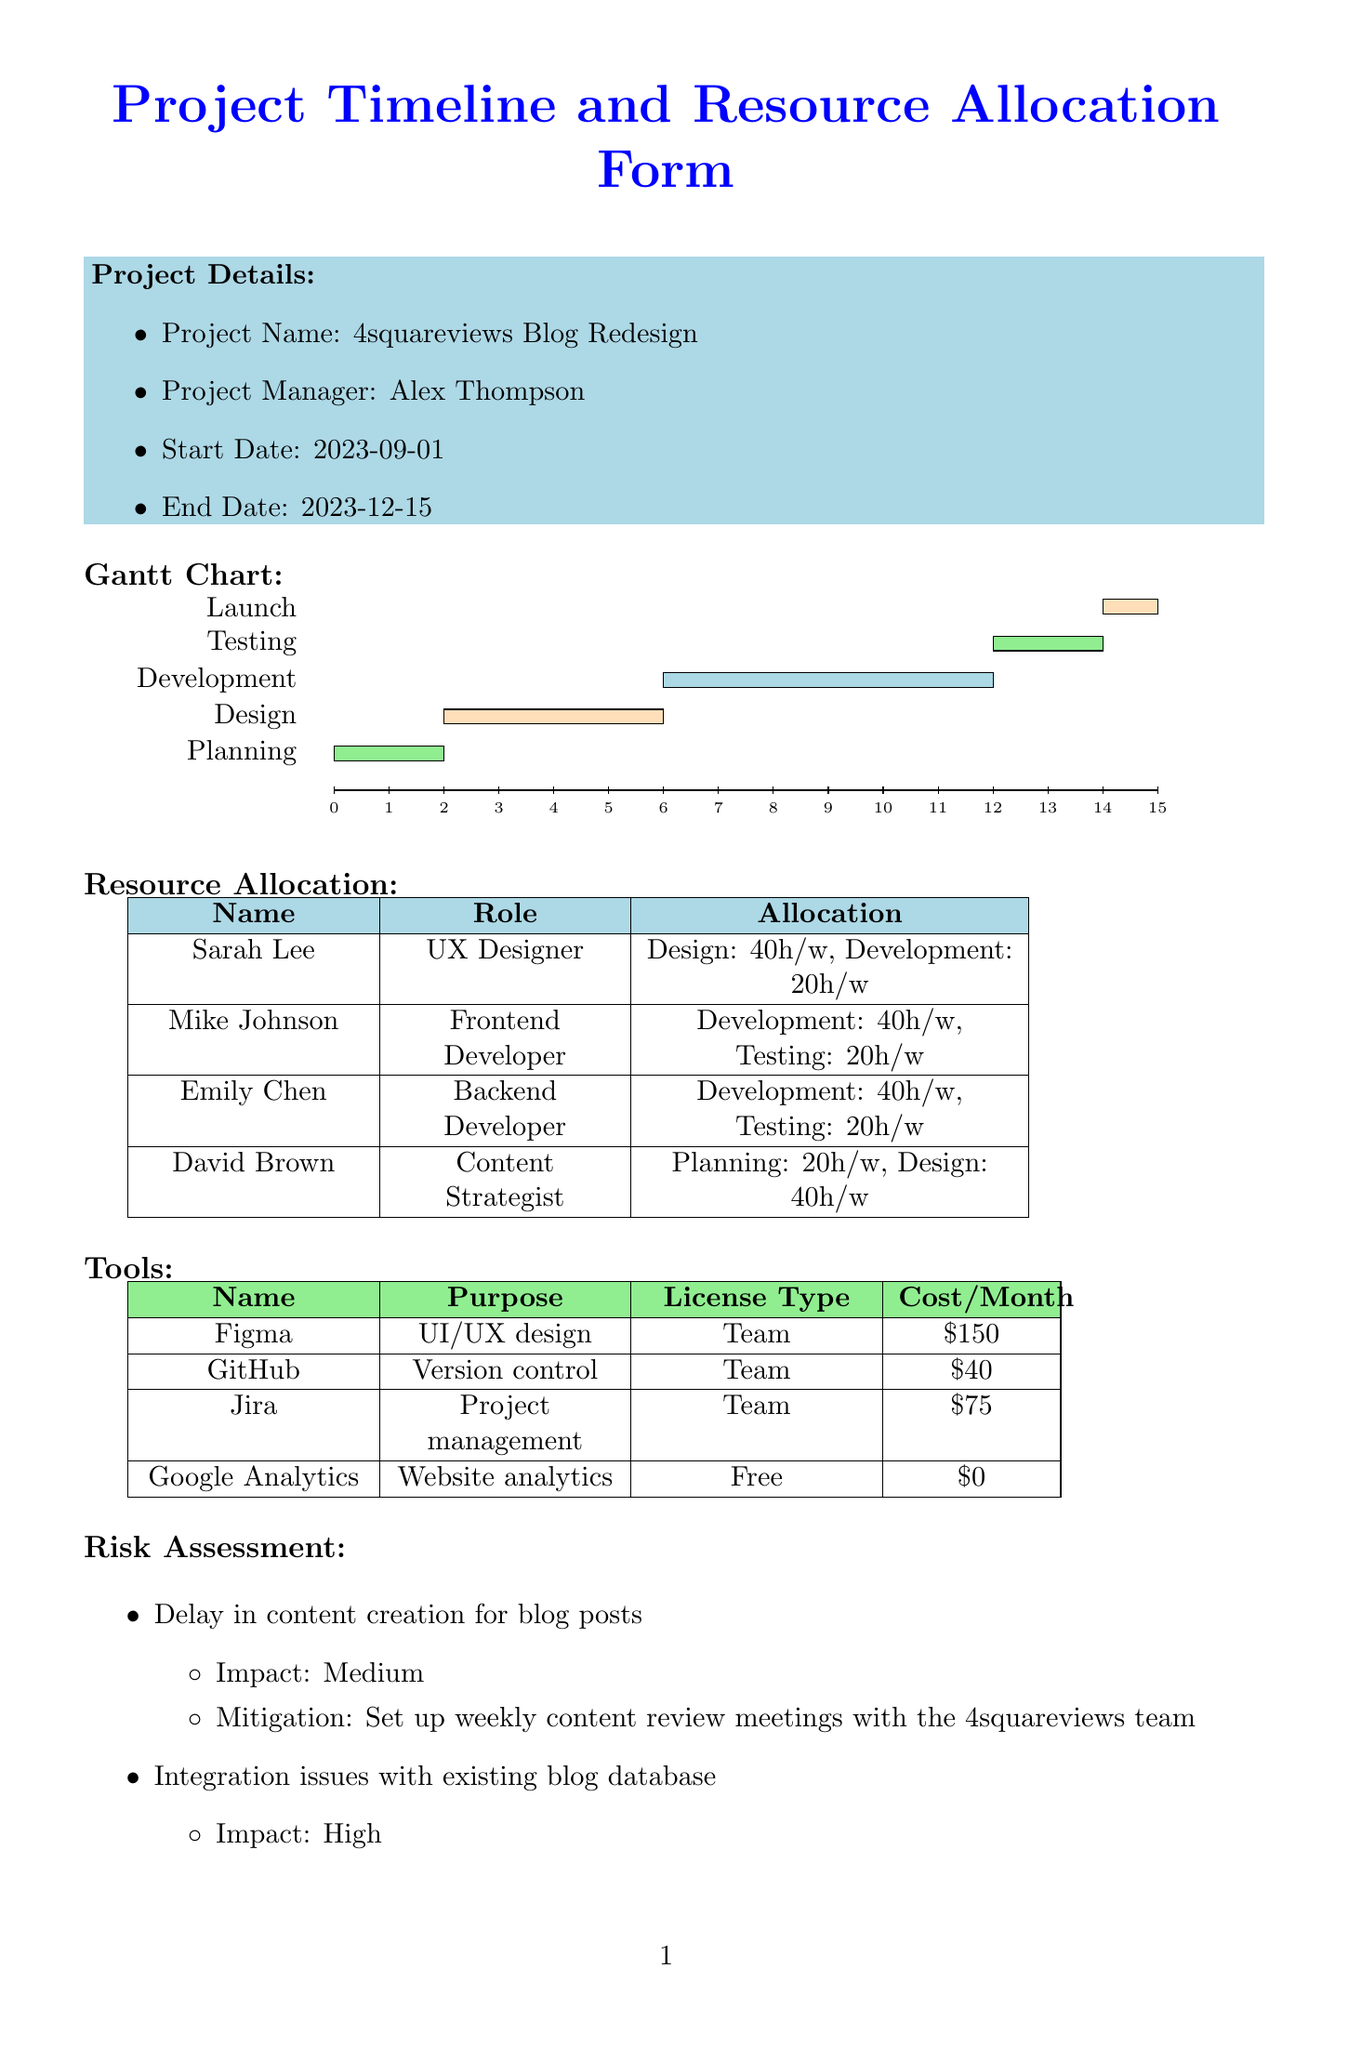What is the project name? The project name is specified in the project details section of the document.
Answer: 4squareviews Blog Redesign Who is the project manager? The project manager's name is listed in the project details section.
Answer: Alex Thompson What is the start date of the project? The start date is provided in the project details section of the document.
Answer: 2023-09-01 How many hours per week is Sarah Lee allocated during the Design phase? Sarah Lee's allocation during the Design phase is stated in the resource allocation section.
Answer: 40 What is the impact level of the risk related to integration issues? The impact level is listed under the risk assessment section for that specific risk.
Answer: High How long is the Development phase scheduled to last? The duration can be calculated from the start and end dates provided in the Gantt chart section.
Answer: 6 weeks What frequency are the stakeholder meetings planned? The frequency of the stakeholder meetings is mentioned under the communication plan section.
Answer: Weekly What is the total cost per month for using Figma? The cost per month of Figma is specified in the tools section of the document.
Answer: 150 How many tasks are listed under the Testing phase? The number of tasks is counted from the Gantt chart section containing the tasks under Testing.
Answer: 3 